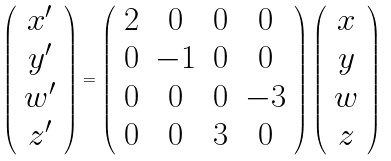<formula> <loc_0><loc_0><loc_500><loc_500>\left ( \begin{array} { c c c c } x ^ { \prime } \\ y ^ { \prime } \\ w ^ { \prime } \\ z ^ { \prime } \\ \end{array} \right ) = \left ( \begin{array} { c c c c } 2 & 0 & 0 & 0 \\ 0 & - 1 & 0 & 0 \\ 0 & 0 & 0 & - 3 \\ 0 & 0 & 3 & 0 \\ \end{array} \right ) \left ( \begin{array} { c c c c } x \\ y \\ w \\ z \\ \end{array} \right )</formula> 